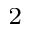<formula> <loc_0><loc_0><loc_500><loc_500>_ { 2 }</formula> 